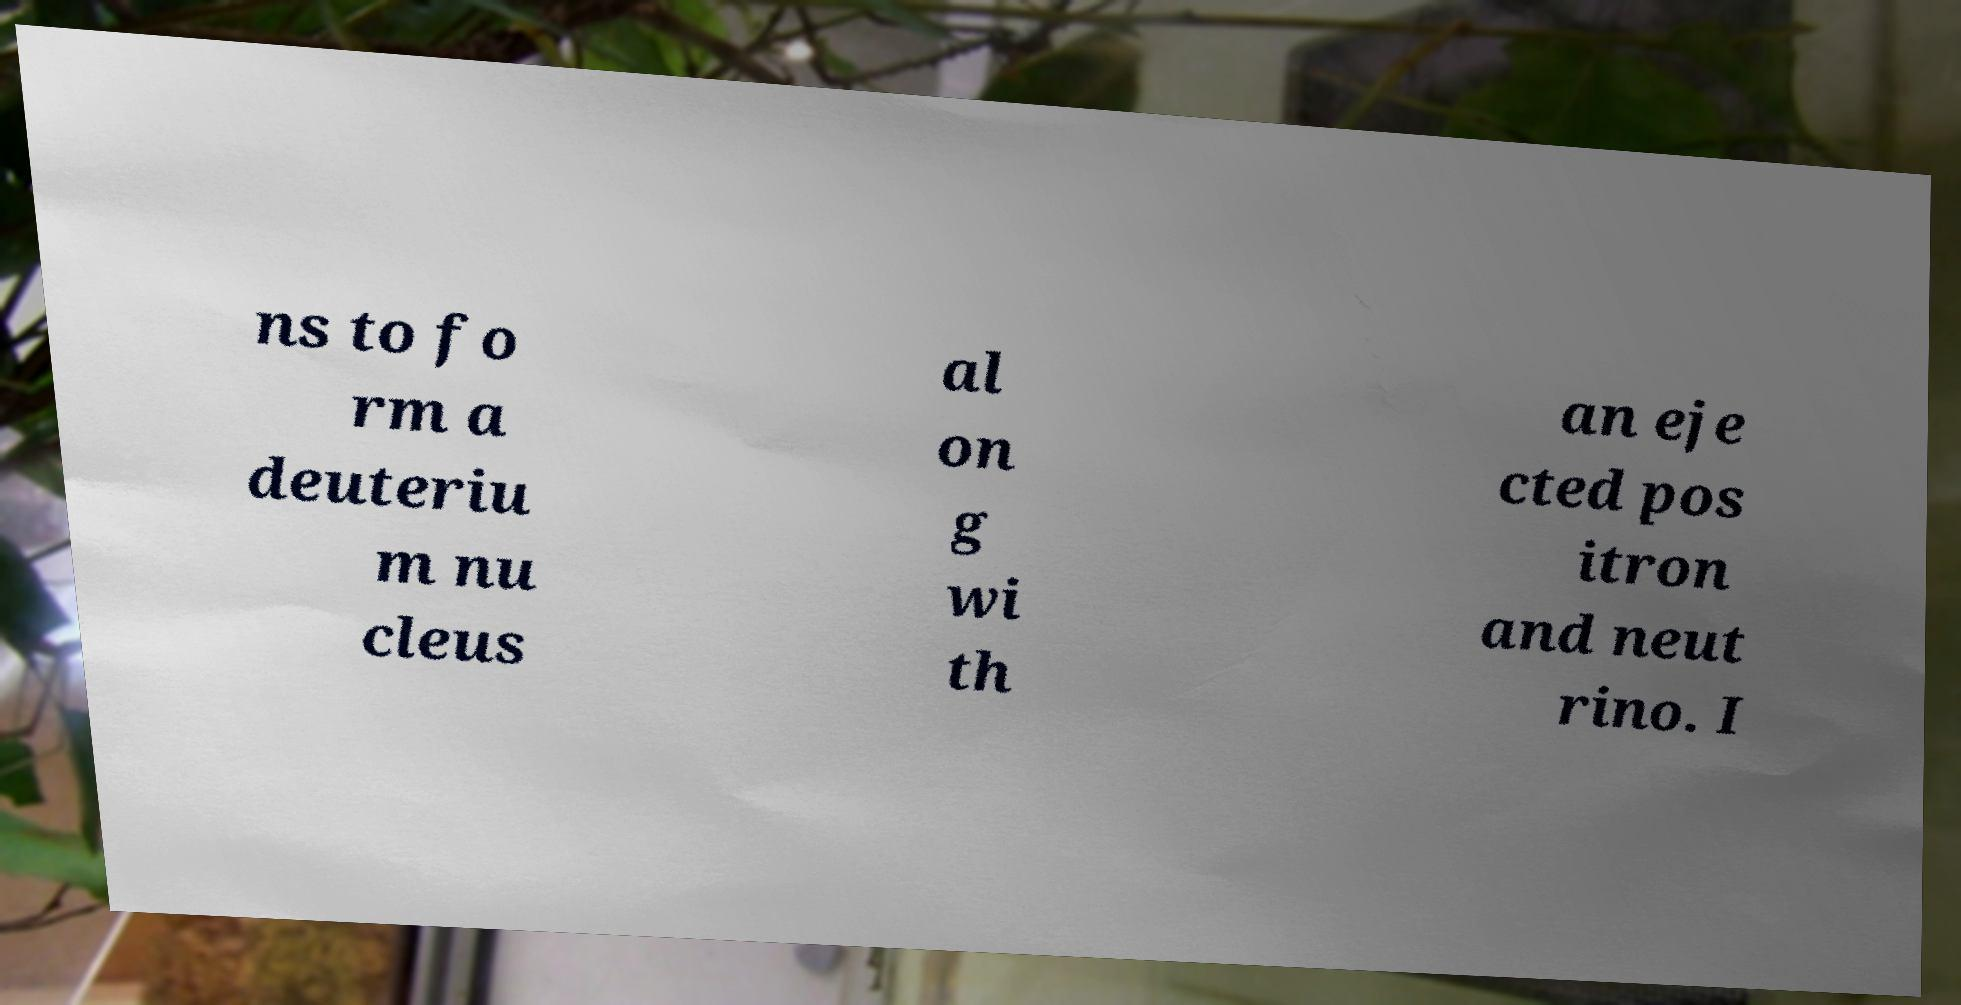For documentation purposes, I need the text within this image transcribed. Could you provide that? ns to fo rm a deuteriu m nu cleus al on g wi th an eje cted pos itron and neut rino. I 